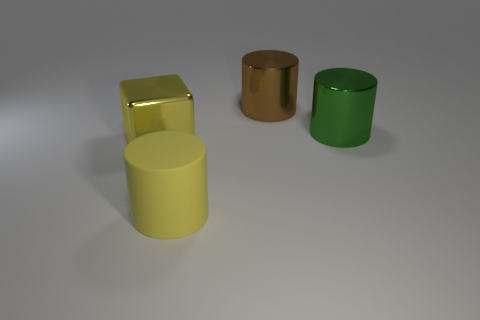There is a green object that is the same shape as the large brown object; what material is it?
Your answer should be compact. Metal. There is a metal object behind the large green shiny cylinder; is it the same shape as the big matte thing?
Give a very brief answer. Yes. There is another large shiny thing that is the same shape as the large brown thing; what color is it?
Your response must be concise. Green. The other big cylinder that is made of the same material as the green cylinder is what color?
Your answer should be compact. Brown. Are there any yellow cylinders that have the same material as the green cylinder?
Offer a terse response. No. How many objects are either large yellow rubber things or large metal cylinders?
Your answer should be compact. 3. Do the brown cylinder and the large cylinder that is in front of the green object have the same material?
Provide a short and direct response. No. There is a cylinder that is in front of the big yellow block; what is its size?
Offer a terse response. Large. Are there fewer large purple matte things than brown cylinders?
Provide a succinct answer. Yes. Are there any metal cylinders of the same color as the matte object?
Your answer should be very brief. No. 